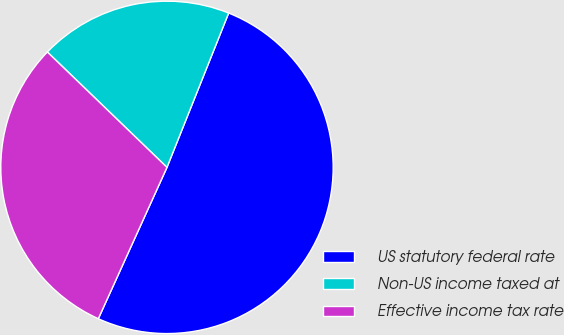Convert chart to OTSL. <chart><loc_0><loc_0><loc_500><loc_500><pie_chart><fcel>US statutory federal rate<fcel>Non-US income taxed at<fcel>Effective income tax rate<nl><fcel>50.72%<fcel>18.84%<fcel>30.43%<nl></chart> 